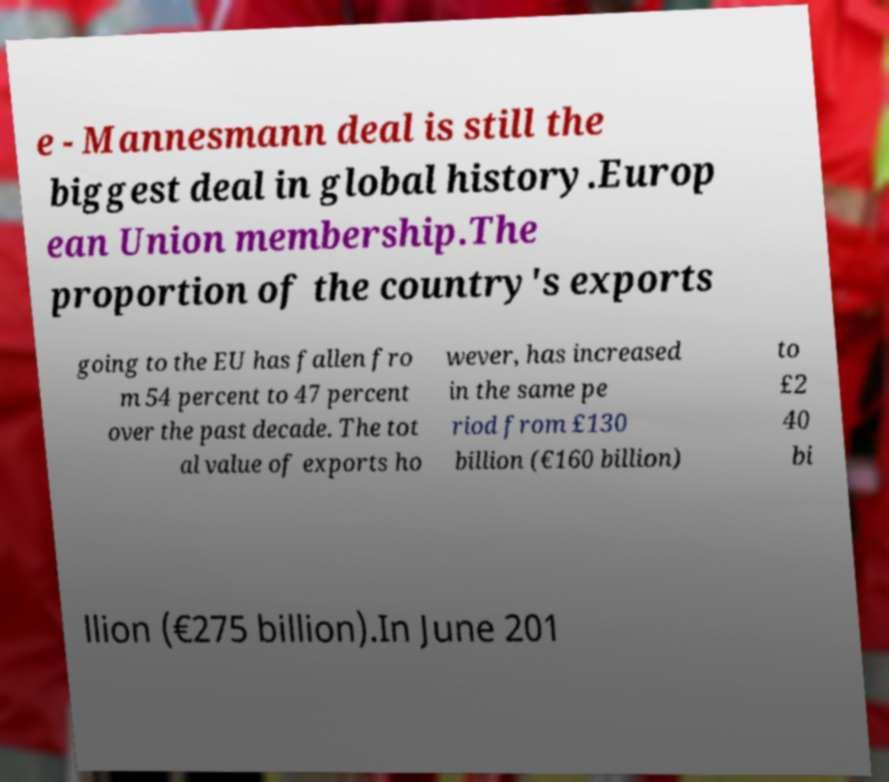Can you accurately transcribe the text from the provided image for me? e - Mannesmann deal is still the biggest deal in global history.Europ ean Union membership.The proportion of the country's exports going to the EU has fallen fro m 54 percent to 47 percent over the past decade. The tot al value of exports ho wever, has increased in the same pe riod from £130 billion (€160 billion) to £2 40 bi llion (€275 billion).In June 201 